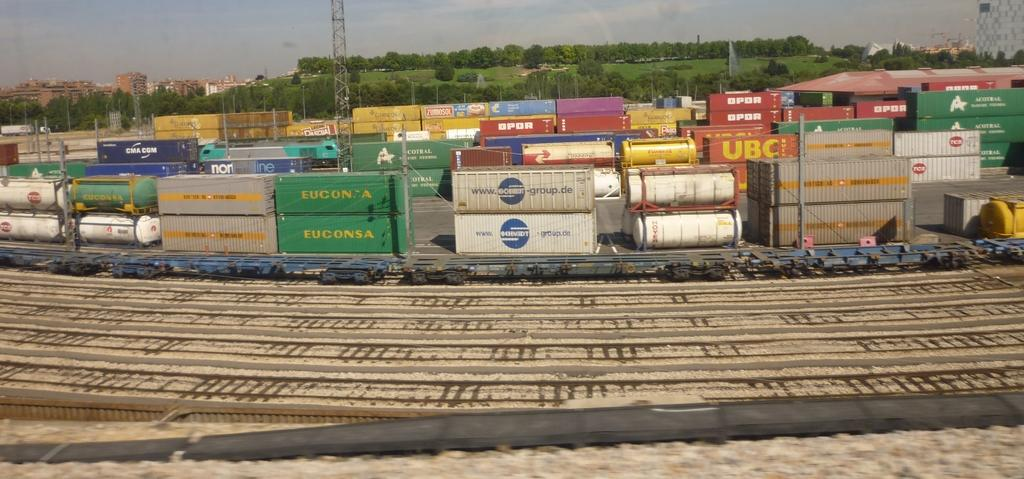<image>
Render a clear and concise summary of the photo. A yard of shipping containers, some of which say EUCONSA. 